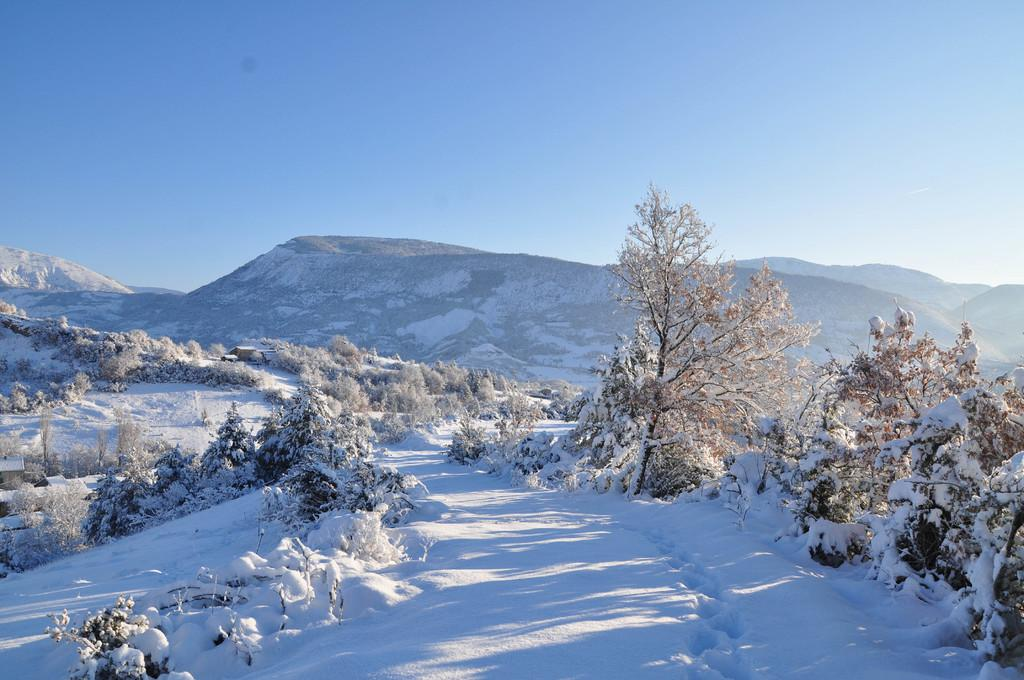What is the main feature in the foreground of the image? There is snow in the foreground of the image. What can be seen in the middle of the image? Trees covered with snow and hills covered with snow are visible in the middle of the image. What is visible at the top of the image? The sky is visible at the top of the image. Where is the giraffe located in the image? There is no giraffe present in the image. What direction is the north indicated in the image? The image does not have any indicators or features to determine the direction of north. 